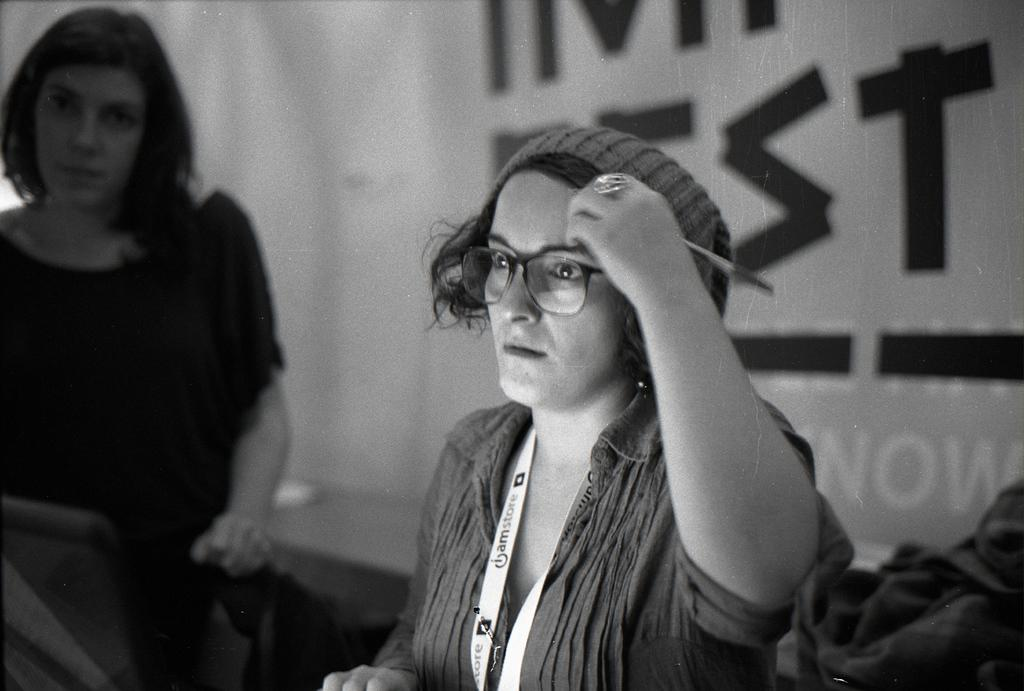What is the color scheme of the image? The image is black and white. How many people are in the image? There are two women in the image. Can you describe any specific clothing or accessories worn by one of the women? One of the women is wearing an identity card. What can be seen on the wall in the background of the image? There is: There is black color text on the wall in the background of the image. Are there any snails visible in the field behind the women in the image? There is no field or snails present in the image; it is a black and white image of two women with text on the wall in the background. 